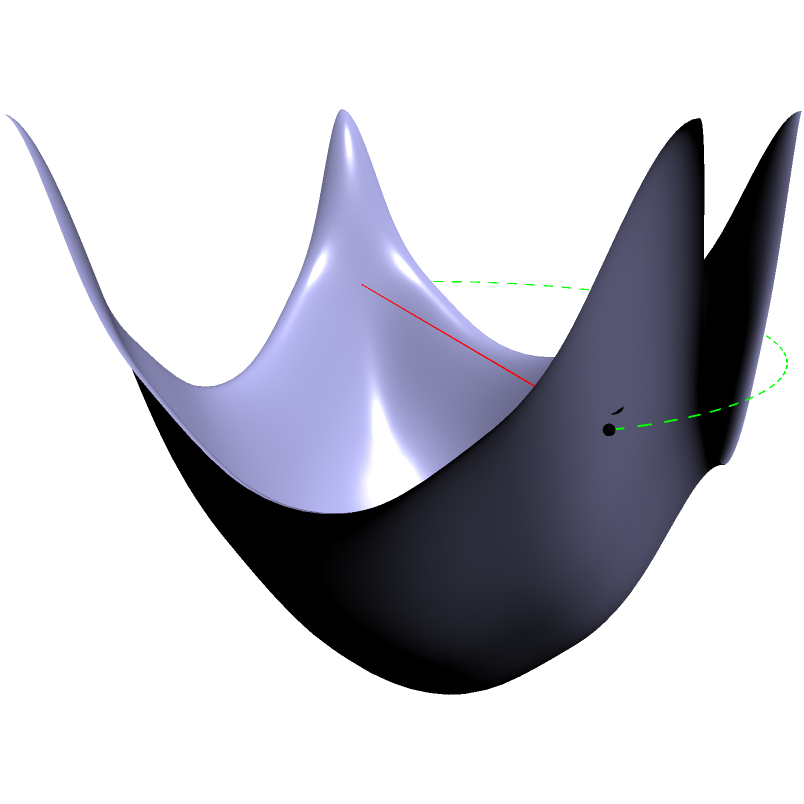As a computer programmer working on optimizing pathfinding algorithms for digital media applications, you encounter a problem involving finding the shortest path between two points on a curved surface. The surface is represented by the function $z = 0.5(x^2 + y^2)$, and the two points are A(-0.8, -0.8, 0.64) and B(0.8, 0.8, 0.64). Which path represents the shortest distance between these points on the surface: the straight line (red) or the curved path (green)? To solve this problem, we need to understand the concept of geodesics on curved surfaces:

1. On a flat surface, the shortest path between two points is always a straight line.

2. However, on a curved surface, the shortest path is not necessarily a straight line in 3D space. Instead, it follows a path called a geodesic.

3. A geodesic is a curve that locally minimizes the distance between points on the surface.

4. In this case, the surface is described by $z = 0.5(x^2 + y^2)$, which is a paraboloid.

5. The red line represents the straight path between A and B in 3D space. While this is the shortest path through the 3D space, it doesn't follow the curvature of the surface.

6. The green curve represents the geodesic path on the surface. It follows the curvature of the paraboloid.

7. Although the green path looks longer in 3D space, it actually represents the shortest path between A and B when constrained to the surface.

8. In digital media applications, such as 3D modeling or game development, using geodesics for pathfinding on curved surfaces can lead to more realistic and efficient results.

Therefore, the curved path (green) represents the shortest distance between the two points when constrained to the surface.
Answer: The curved path (green) 